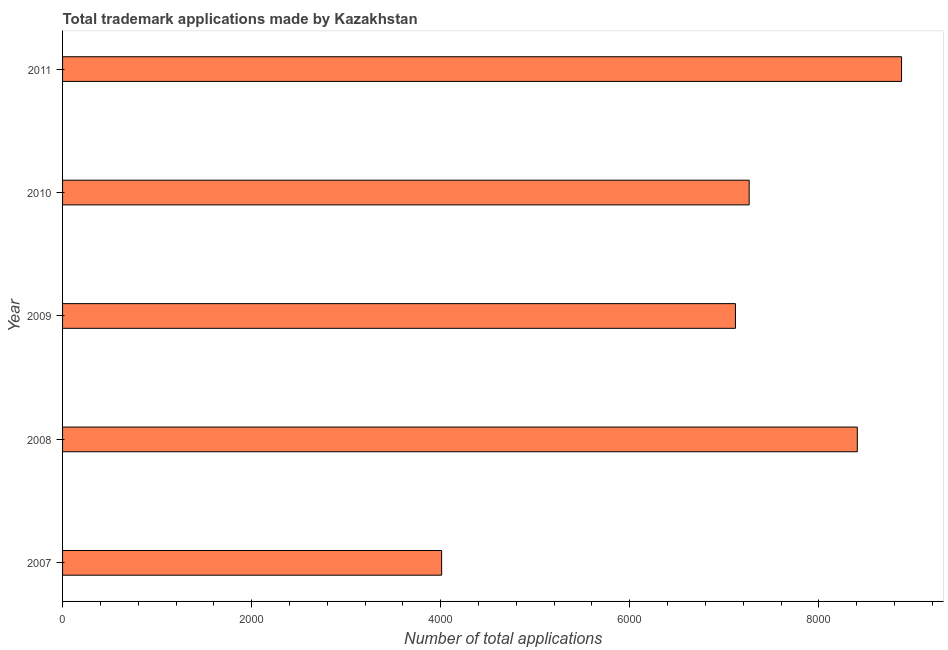What is the title of the graph?
Provide a succinct answer. Total trademark applications made by Kazakhstan. What is the label or title of the X-axis?
Provide a short and direct response. Number of total applications. What is the label or title of the Y-axis?
Provide a succinct answer. Year. What is the number of trademark applications in 2011?
Provide a succinct answer. 8875. Across all years, what is the maximum number of trademark applications?
Offer a terse response. 8875. Across all years, what is the minimum number of trademark applications?
Keep it short and to the point. 4010. In which year was the number of trademark applications maximum?
Make the answer very short. 2011. In which year was the number of trademark applications minimum?
Provide a short and direct response. 2007. What is the sum of the number of trademark applications?
Keep it short and to the point. 3.57e+04. What is the difference between the number of trademark applications in 2008 and 2010?
Make the answer very short. 1144. What is the average number of trademark applications per year?
Provide a short and direct response. 7134. What is the median number of trademark applications?
Give a very brief answer. 7263. Is the difference between the number of trademark applications in 2007 and 2009 greater than the difference between any two years?
Provide a short and direct response. No. What is the difference between the highest and the second highest number of trademark applications?
Ensure brevity in your answer.  468. Is the sum of the number of trademark applications in 2008 and 2009 greater than the maximum number of trademark applications across all years?
Give a very brief answer. Yes. What is the difference between the highest and the lowest number of trademark applications?
Provide a short and direct response. 4865. How many years are there in the graph?
Ensure brevity in your answer.  5. What is the difference between two consecutive major ticks on the X-axis?
Provide a short and direct response. 2000. What is the Number of total applications in 2007?
Ensure brevity in your answer.  4010. What is the Number of total applications in 2008?
Keep it short and to the point. 8407. What is the Number of total applications in 2009?
Your answer should be compact. 7118. What is the Number of total applications in 2010?
Offer a very short reply. 7263. What is the Number of total applications of 2011?
Your answer should be very brief. 8875. What is the difference between the Number of total applications in 2007 and 2008?
Your response must be concise. -4397. What is the difference between the Number of total applications in 2007 and 2009?
Your response must be concise. -3108. What is the difference between the Number of total applications in 2007 and 2010?
Your answer should be very brief. -3253. What is the difference between the Number of total applications in 2007 and 2011?
Your answer should be compact. -4865. What is the difference between the Number of total applications in 2008 and 2009?
Provide a succinct answer. 1289. What is the difference between the Number of total applications in 2008 and 2010?
Give a very brief answer. 1144. What is the difference between the Number of total applications in 2008 and 2011?
Provide a succinct answer. -468. What is the difference between the Number of total applications in 2009 and 2010?
Your response must be concise. -145. What is the difference between the Number of total applications in 2009 and 2011?
Provide a succinct answer. -1757. What is the difference between the Number of total applications in 2010 and 2011?
Your response must be concise. -1612. What is the ratio of the Number of total applications in 2007 to that in 2008?
Give a very brief answer. 0.48. What is the ratio of the Number of total applications in 2007 to that in 2009?
Give a very brief answer. 0.56. What is the ratio of the Number of total applications in 2007 to that in 2010?
Your answer should be compact. 0.55. What is the ratio of the Number of total applications in 2007 to that in 2011?
Your response must be concise. 0.45. What is the ratio of the Number of total applications in 2008 to that in 2009?
Give a very brief answer. 1.18. What is the ratio of the Number of total applications in 2008 to that in 2010?
Your answer should be compact. 1.16. What is the ratio of the Number of total applications in 2008 to that in 2011?
Ensure brevity in your answer.  0.95. What is the ratio of the Number of total applications in 2009 to that in 2010?
Make the answer very short. 0.98. What is the ratio of the Number of total applications in 2009 to that in 2011?
Keep it short and to the point. 0.8. What is the ratio of the Number of total applications in 2010 to that in 2011?
Keep it short and to the point. 0.82. 